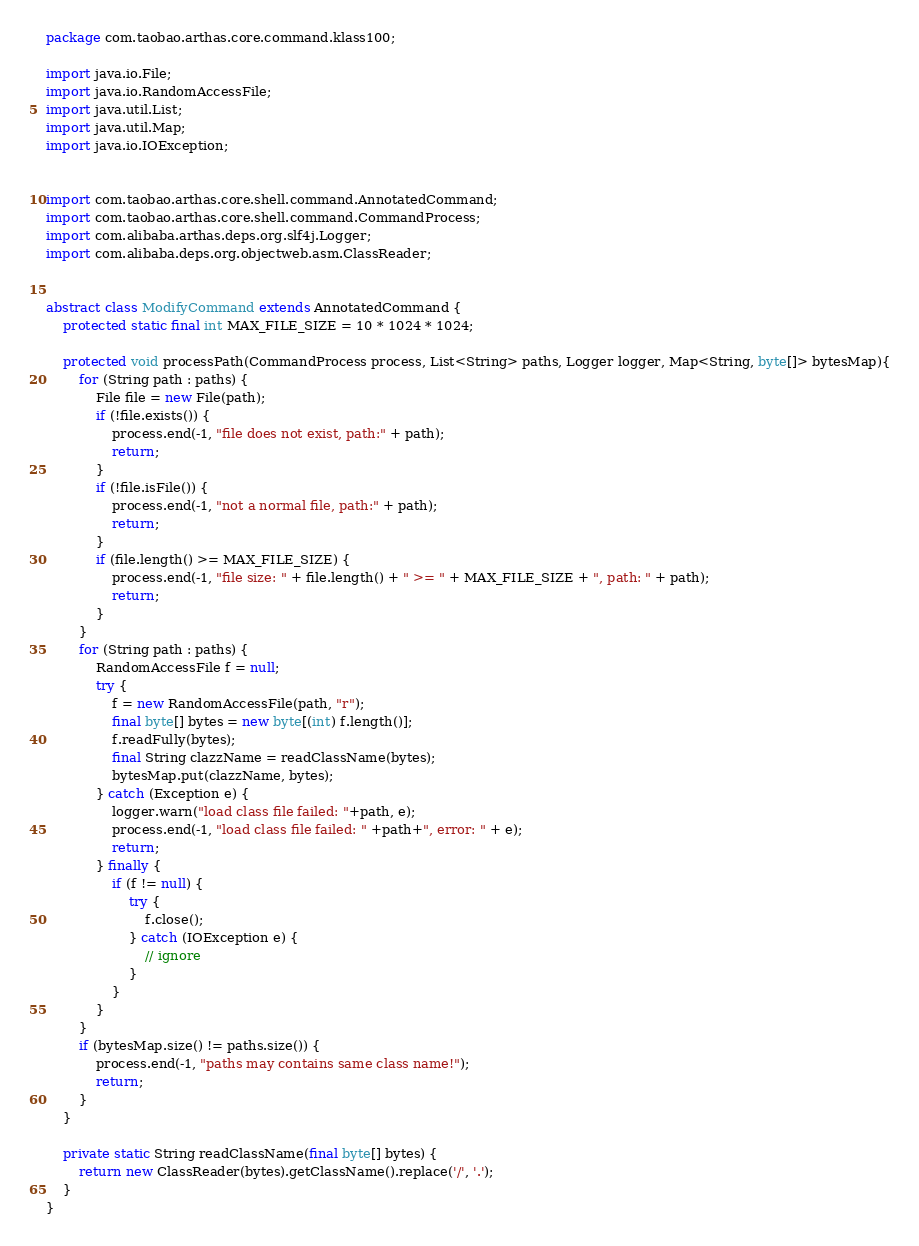<code> <loc_0><loc_0><loc_500><loc_500><_Java_>package com.taobao.arthas.core.command.klass100;

import java.io.File;
import java.io.RandomAccessFile;
import java.util.List;
import java.util.Map;
import java.io.IOException;


import com.taobao.arthas.core.shell.command.AnnotatedCommand;
import com.taobao.arthas.core.shell.command.CommandProcess;
import com.alibaba.arthas.deps.org.slf4j.Logger;
import com.alibaba.deps.org.objectweb.asm.ClassReader;


abstract class ModifyCommand extends AnnotatedCommand {
    protected static final int MAX_FILE_SIZE = 10 * 1024 * 1024;

    protected void processPath(CommandProcess process, List<String> paths, Logger logger, Map<String, byte[]> bytesMap){
        for (String path : paths) {
            File file = new File(path);
            if (!file.exists()) {
                process.end(-1, "file does not exist, path:" + path);
                return;
            }
            if (!file.isFile()) {
                process.end(-1, "not a normal file, path:" + path);
                return;
            }
            if (file.length() >= MAX_FILE_SIZE) {
                process.end(-1, "file size: " + file.length() + " >= " + MAX_FILE_SIZE + ", path: " + path);
                return;
            }
        }
        for (String path : paths) {
            RandomAccessFile f = null;
            try {
                f = new RandomAccessFile(path, "r");
                final byte[] bytes = new byte[(int) f.length()];
                f.readFully(bytes);
                final String clazzName = readClassName(bytes);
                bytesMap.put(clazzName, bytes);
            } catch (Exception e) {
                logger.warn("load class file failed: "+path, e);
                process.end(-1, "load class file failed: " +path+", error: " + e);
                return;
            } finally {
                if (f != null) {
                    try {
                        f.close();
                    } catch (IOException e) {
                        // ignore
                    }
                }
            }
        }
        if (bytesMap.size() != paths.size()) {
            process.end(-1, "paths may contains same class name!");
            return;
        }
    }

    private static String readClassName(final byte[] bytes) {
        return new ClassReader(bytes).getClassName().replace('/', '.');
    }
}</code> 